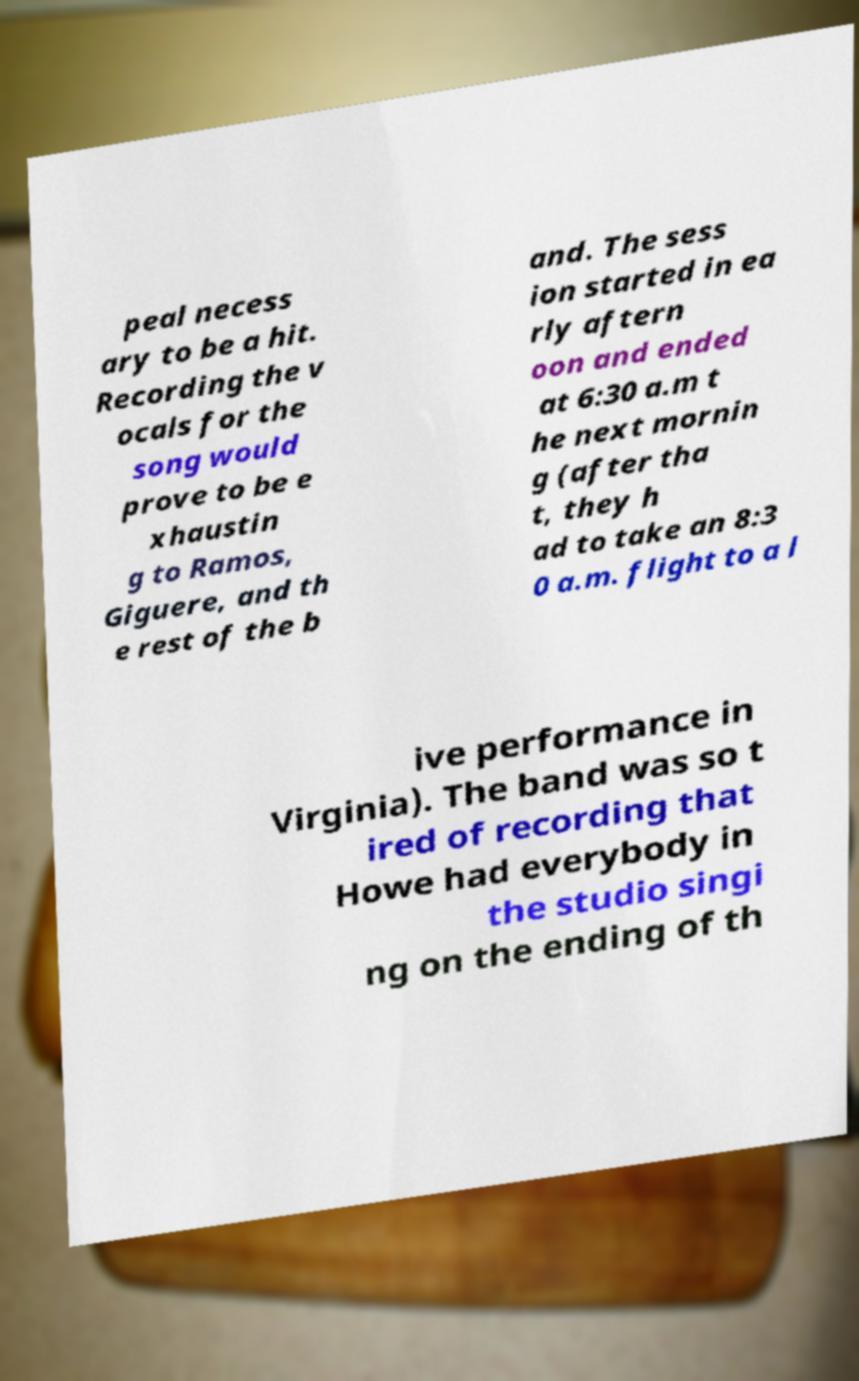Could you extract and type out the text from this image? peal necess ary to be a hit. Recording the v ocals for the song would prove to be e xhaustin g to Ramos, Giguere, and th e rest of the b and. The sess ion started in ea rly aftern oon and ended at 6:30 a.m t he next mornin g (after tha t, they h ad to take an 8:3 0 a.m. flight to a l ive performance in Virginia). The band was so t ired of recording that Howe had everybody in the studio singi ng on the ending of th 